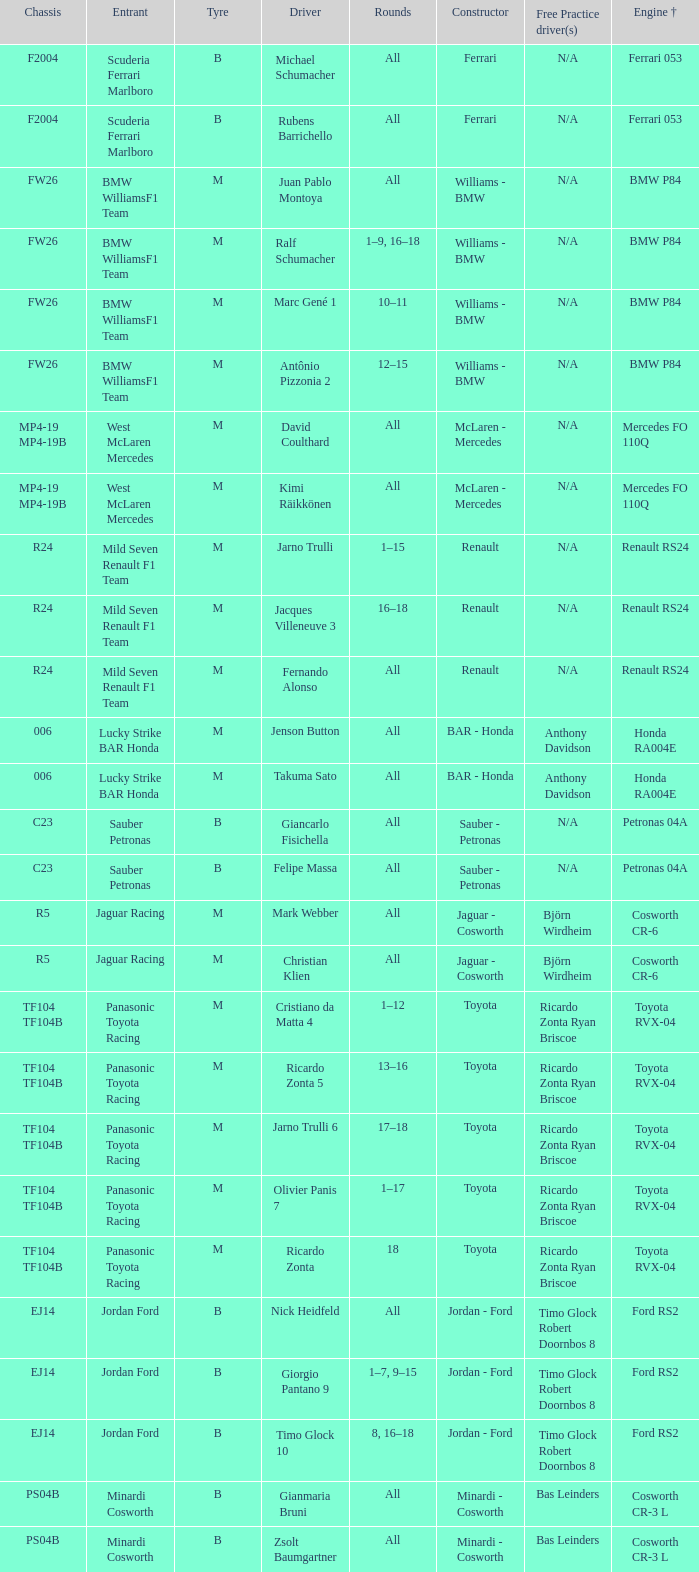What kind of chassis does Ricardo Zonta have? TF104 TF104B. 